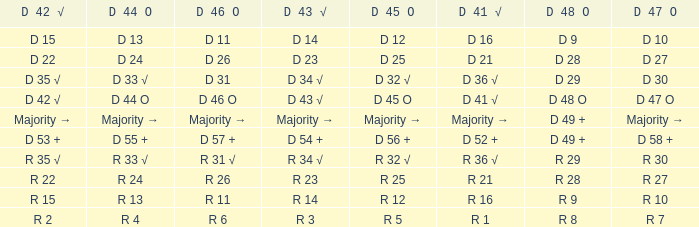Name the D 45 O with D 44 O majority → Majority →. 